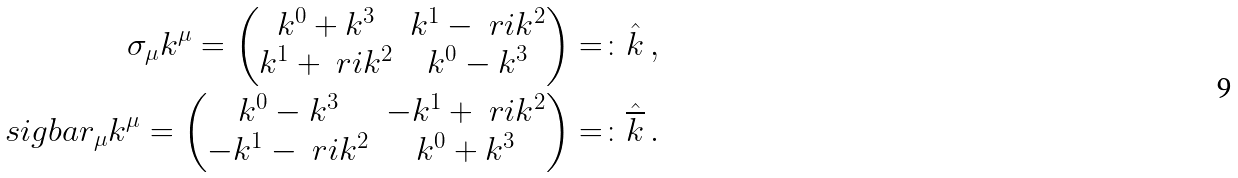Convert formula to latex. <formula><loc_0><loc_0><loc_500><loc_500>\sigma _ { \mu } k ^ { \mu } = \begin{pmatrix} k ^ { 0 } + k ^ { 3 } & k ^ { 1 } - \ r i k ^ { 2 } \\ k ^ { 1 } + \ r i k ^ { 2 } & k ^ { 0 } - k ^ { 3 } \end{pmatrix} = \colon \hat { k } \, , \\ \ s i g b a r _ { \mu } k ^ { \mu } = \begin{pmatrix} k ^ { 0 } - k ^ { 3 } & - k ^ { 1 } + \ r i k ^ { 2 } \\ - k ^ { 1 } - \ r i k ^ { 2 } & k ^ { 0 } + k ^ { 3 } \end{pmatrix} = \colon \hat { \overline { k } } \, .</formula> 